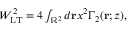Convert formula to latex. <formula><loc_0><loc_0><loc_500><loc_500>\begin{array} { r } { W _ { L T } ^ { 2 } = 4 \int _ { \mathbb { R } ^ { 2 } } d r x ^ { 2 } \Gamma _ { 2 } ( r ; z ) , } \end{array}</formula> 